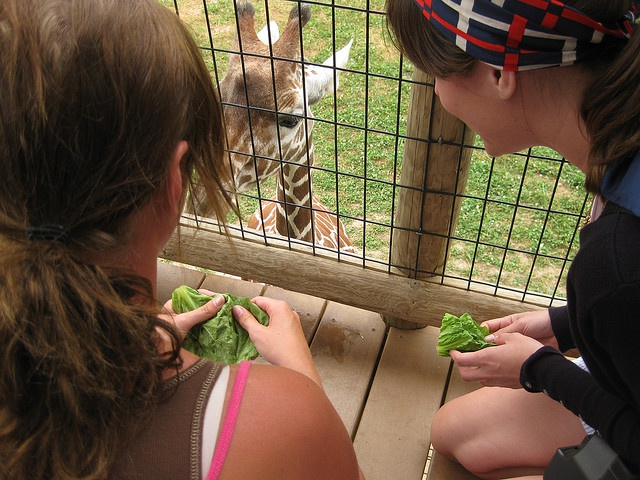Describe the objects in this image and their specific colors. I can see people in brown, black, and maroon tones, people in brown, black, and maroon tones, and giraffe in brown, maroon, black, gray, and tan tones in this image. 